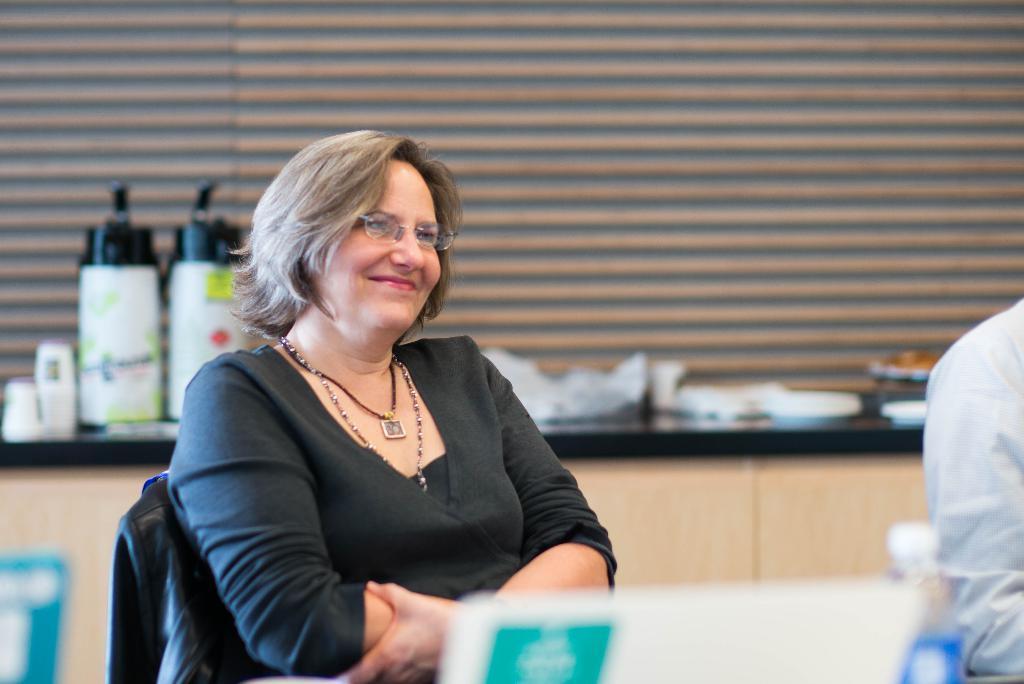How would you summarize this image in a sentence or two? In this picture there is a woman wearing black dress is sitting in the chair and there is another person sitting beside her and there are few other objects in the background. 